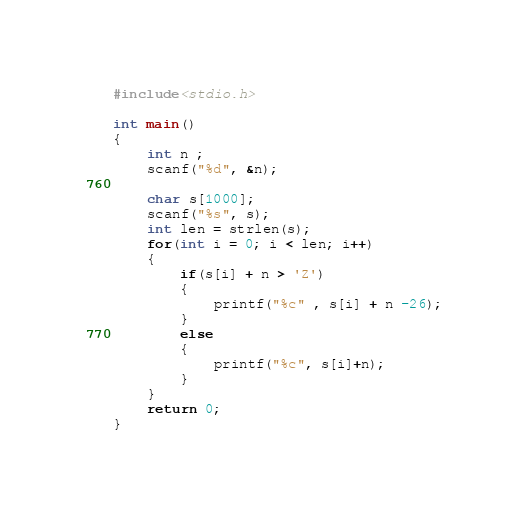Convert code to text. <code><loc_0><loc_0><loc_500><loc_500><_C_>#include<stdio.h>

int main()
{
    int n ;
    scanf("%d", &n);

    char s[1000];
    scanf("%s", s);
    int len = strlen(s);
    for(int i = 0; i < len; i++)
    {
        if(s[i] + n > 'Z')
        {
            printf("%c" , s[i] + n -26);
        }
        else
        {
            printf("%c", s[i]+n);
        }
    }
    return 0;
}
</code> 